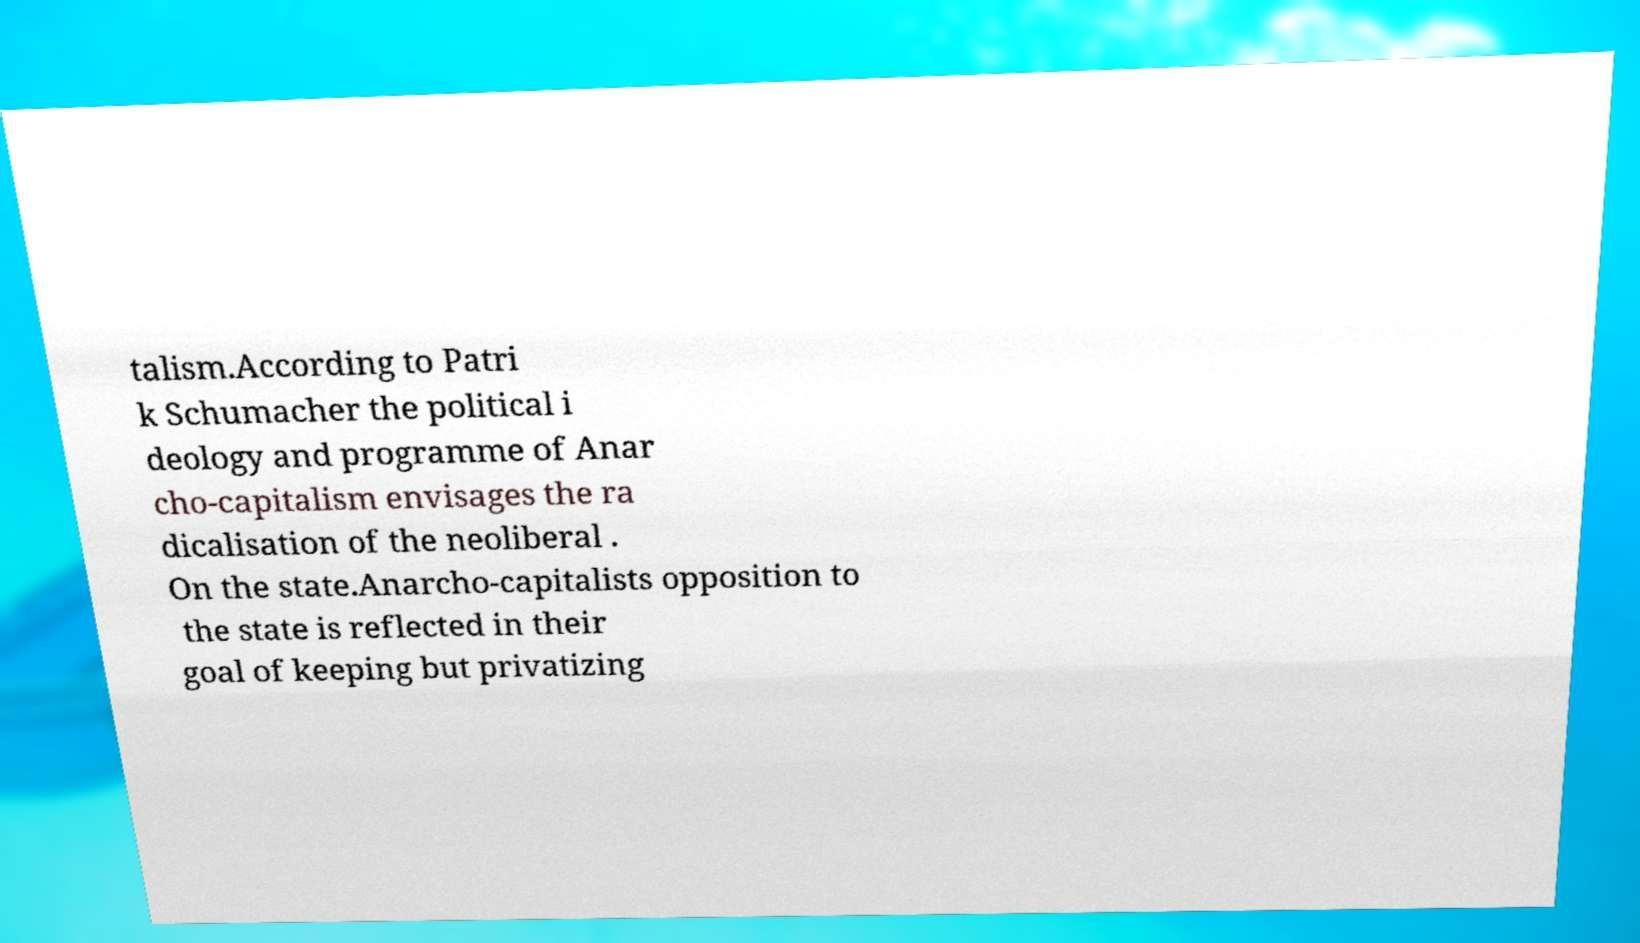I need the written content from this picture converted into text. Can you do that? talism.According to Patri k Schumacher the political i deology and programme of Anar cho-capitalism envisages the ra dicalisation of the neoliberal . On the state.Anarcho-capitalists opposition to the state is reflected in their goal of keeping but privatizing 